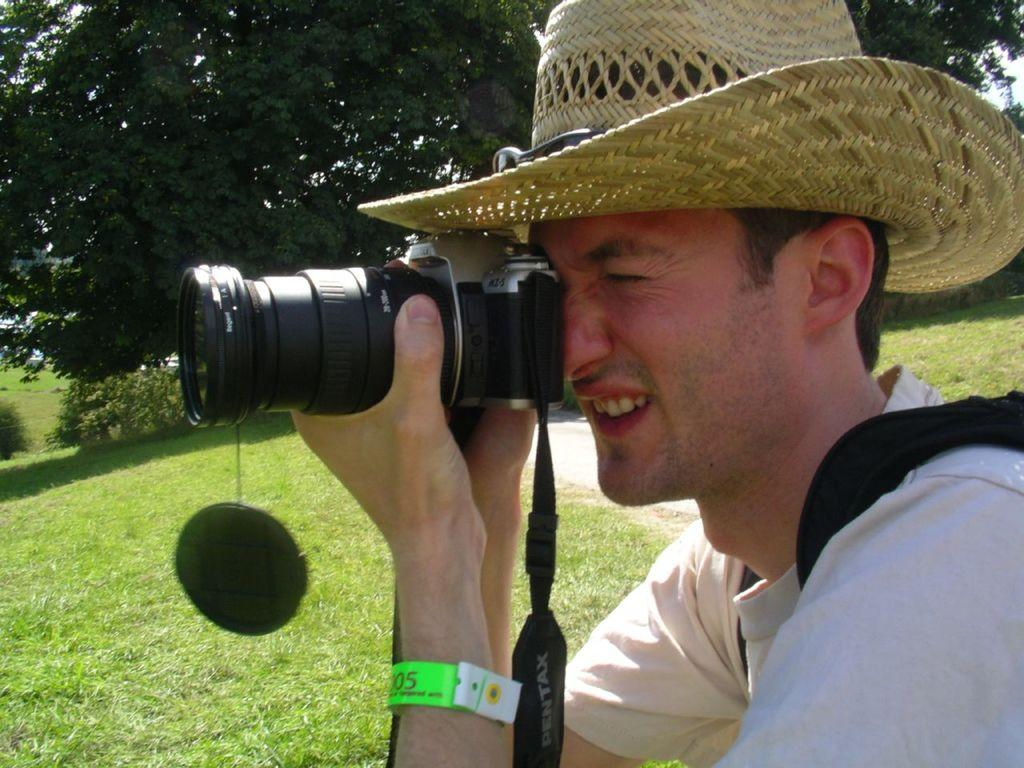Who is present in the image? There is a man in the picture. What is the man wearing on his head? The man is wearing a hat. What is the man holding in his hands? The man is holding a camera. What is the man doing with the camera? The man is taking a picture. What type of vegetation can be seen on the land in the image? There is grass on the land in the image. What can be seen in the distance behind the man? There are trees in the background of the image. What is the order of the planets in the image? There are no planets present in the image; it features a man taking a picture with a camera. 